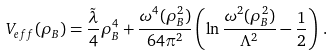Convert formula to latex. <formula><loc_0><loc_0><loc_500><loc_500>V _ { e f f } ( \rho _ { B } ) = \frac { \tilde { \lambda } } { 4 } \rho ^ { 4 } _ { B } + \frac { \omega ^ { 4 } ( \rho ^ { 2 } _ { B } ) } { 6 4 \pi ^ { 2 } } \left ( \ln \frac { \omega ^ { 2 } ( \rho ^ { 2 } _ { B } ) } { \Lambda ^ { 2 } } - \frac { 1 } { 2 } \right ) \, .</formula> 